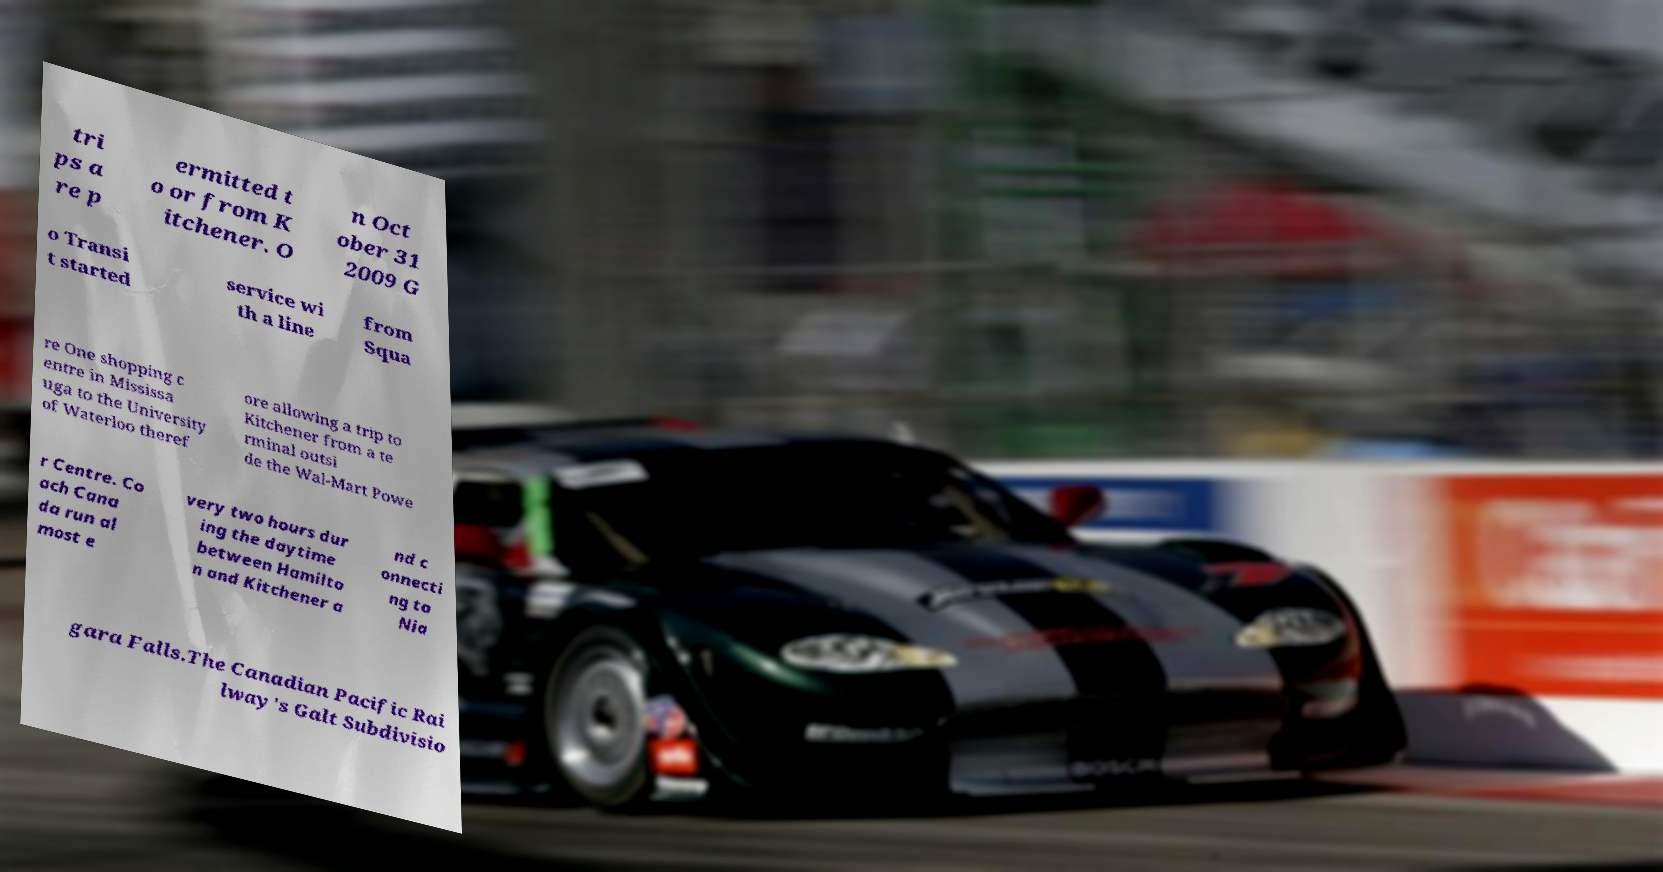Please read and relay the text visible in this image. What does it say? tri ps a re p ermitted t o or from K itchener. O n Oct ober 31 2009 G o Transi t started service wi th a line from Squa re One shopping c entre in Mississa uga to the University of Waterloo theref ore allowing a trip to Kitchener from a te rminal outsi de the Wal-Mart Powe r Centre. Co ach Cana da run al most e very two hours dur ing the daytime between Hamilto n and Kitchener a nd c onnecti ng to Nia gara Falls.The Canadian Pacific Rai lway's Galt Subdivisio 